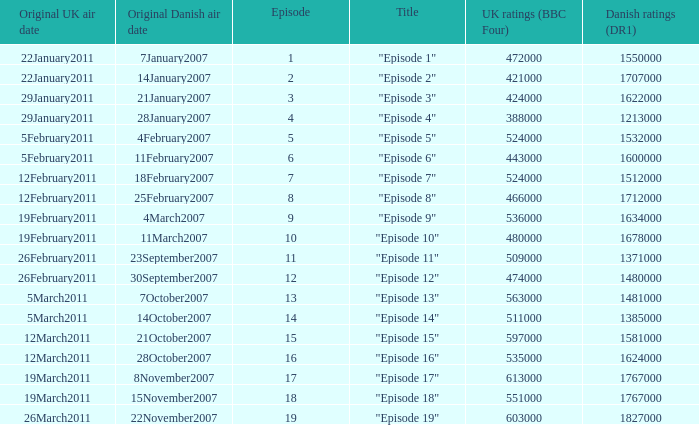What is the original Danish air date of "Episode 17"?  8November2007. 